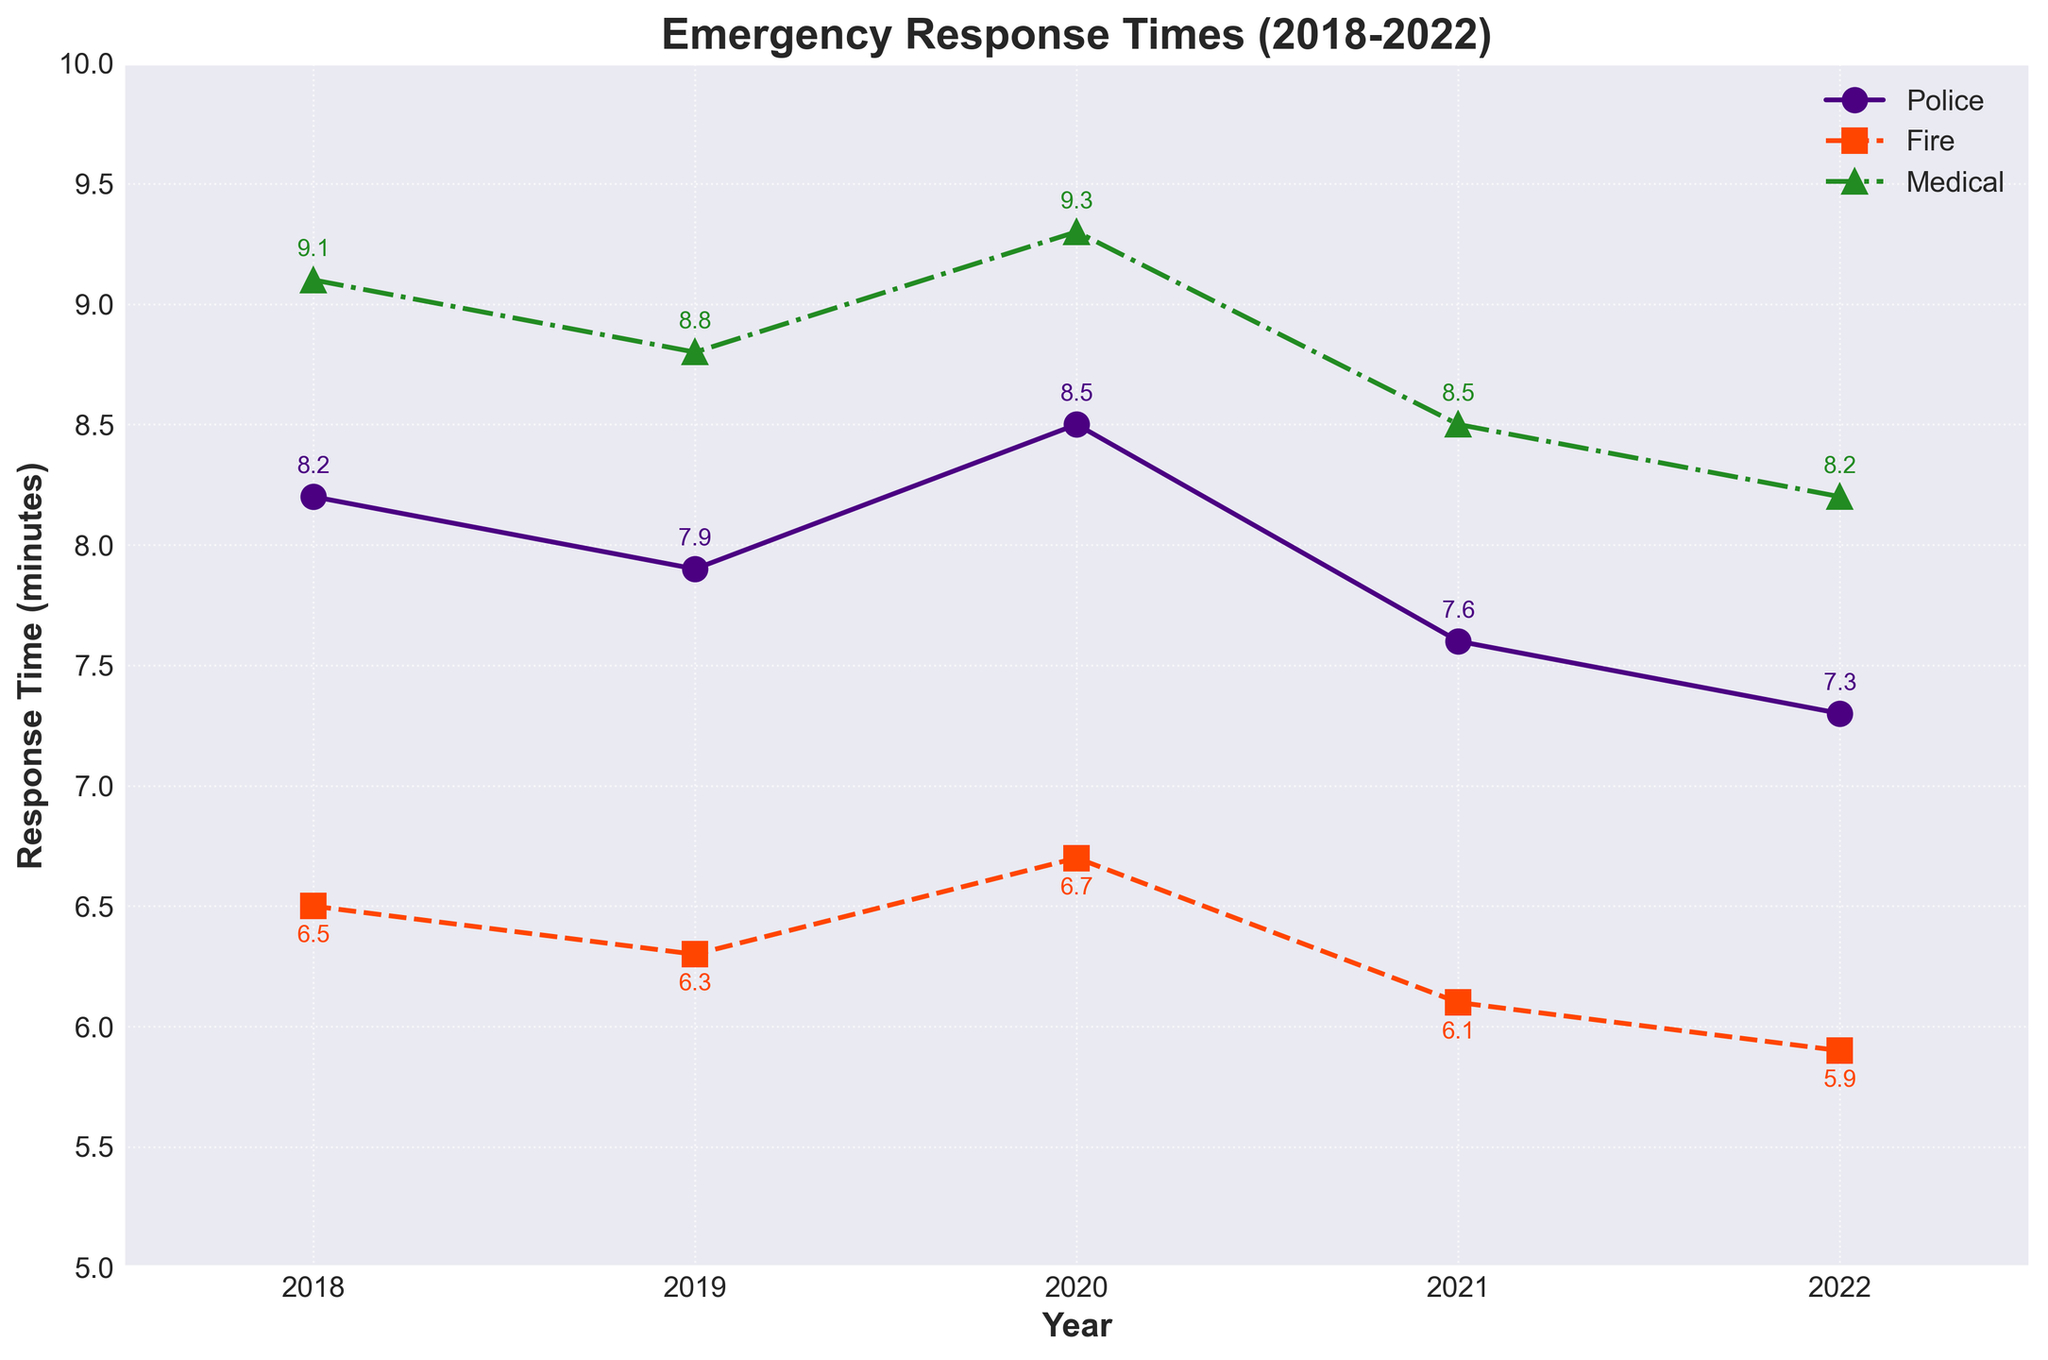What's the trend of the police response times from 2018 to 2022? Observing the line representing Police response times, we see a decreasing trend from 8.2 minutes in 2018 to 7.3 minutes in 2022.
Answer: Decreasing Were there any years where all three services had the same response time? By comparing the response times for each year, there is no year in which police, fire, and medical services all have the same response time.
Answer: No Which emergency service had the best overall improvement from 2018 to 2022? Comparing the initial and final response times, Police improved from 8.2 to 7.3 (0.9 minutes), Fire improved from 6.5 to 5.9 (0.6 minutes), and Medical improved from 9.1 to 8.2 (0.9 minutes). Both Police and Medical showed the same improvement of 0.9 minutes.
Answer: Police and Medical In 2020, which emergency service had the longest response time? In 2020, looking at the values, Police had 8.5 minutes, Fire had 6.7 minutes, and Medical had 9.3 minutes. The Medical response time was the longest.
Answer: Medical How much did the fire response time decrease from 2018 to 2022? The fire response time in 2018 was 6.5 minutes and decreased to 5.9 minutes in 2022. The decrease is 6.5 - 5.9 = 0.6 minutes.
Answer: 0.6 minutes Which emergency service showed the least variation in their response times over the years? Police response times ranged from 7.3 to 8.5 (1.2 minutes variation), Fire from 5.9 to 6.7 (0.8 minutes variation), and Medical from 8.2 to 9.3 (1.1 minutes variation). Fire service showed the least variation.
Answer: Fire How did the medical response time in 2022 compare to that in 2019? The medical response time in 2022 was 8.2 minutes, while in 2019 it was 8.8 minutes. Therefore, the response time decreased by 8.8 - 8.2 = 0.6 minutes.
Answer: Decreased by 0.6 minutes What was the average response time for police over the 5 years? Adding police response times from 2018 to 2022: 8.2 + 7.9 + 8.5 + 7.6 + 7.3 = 39.5. Dividing by 5 years, the average is 39.5 / 5 = 7.9 minutes.
Answer: 7.9 minutes 